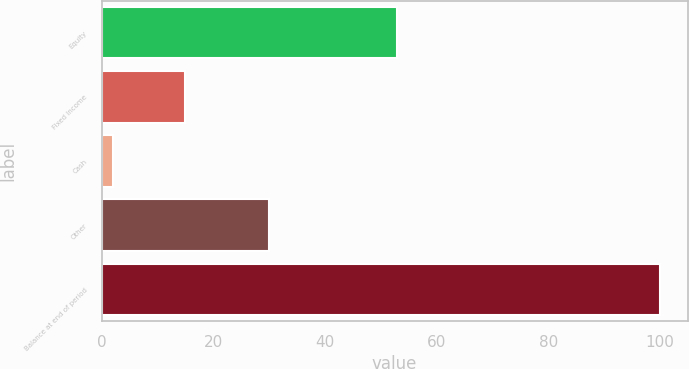Convert chart to OTSL. <chart><loc_0><loc_0><loc_500><loc_500><bar_chart><fcel>Equity<fcel>Fixed Income<fcel>Cash<fcel>Other<fcel>Balance at end of period<nl><fcel>53<fcel>15<fcel>2<fcel>30<fcel>100<nl></chart> 